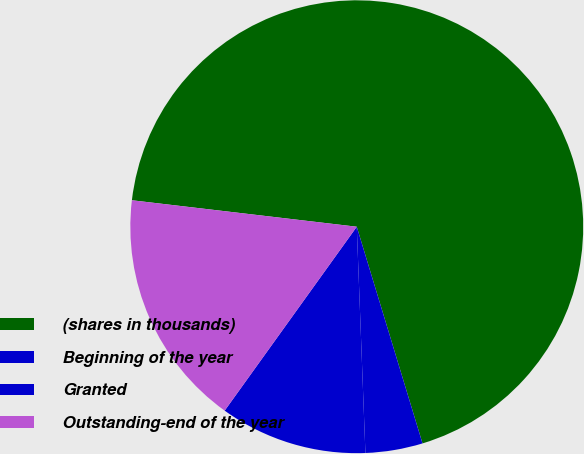Convert chart to OTSL. <chart><loc_0><loc_0><loc_500><loc_500><pie_chart><fcel>(shares in thousands)<fcel>Beginning of the year<fcel>Granted<fcel>Outstanding-end of the year<nl><fcel>68.44%<fcel>4.08%<fcel>10.52%<fcel>16.95%<nl></chart> 